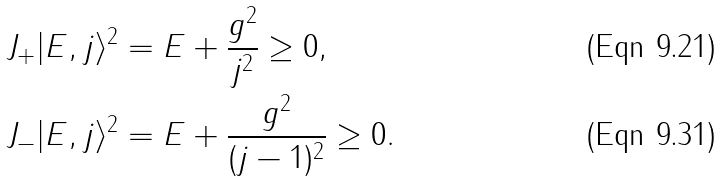<formula> <loc_0><loc_0><loc_500><loc_500>\| J _ { + } | E , j \rangle \| ^ { 2 } & = E + \frac { g ^ { 2 } } { j ^ { 2 } } \geq 0 , \\ \| J _ { - } | E , j \rangle \| ^ { 2 } & = E + \frac { g ^ { 2 } } { ( j - 1 ) ^ { 2 } } \geq 0 .</formula> 